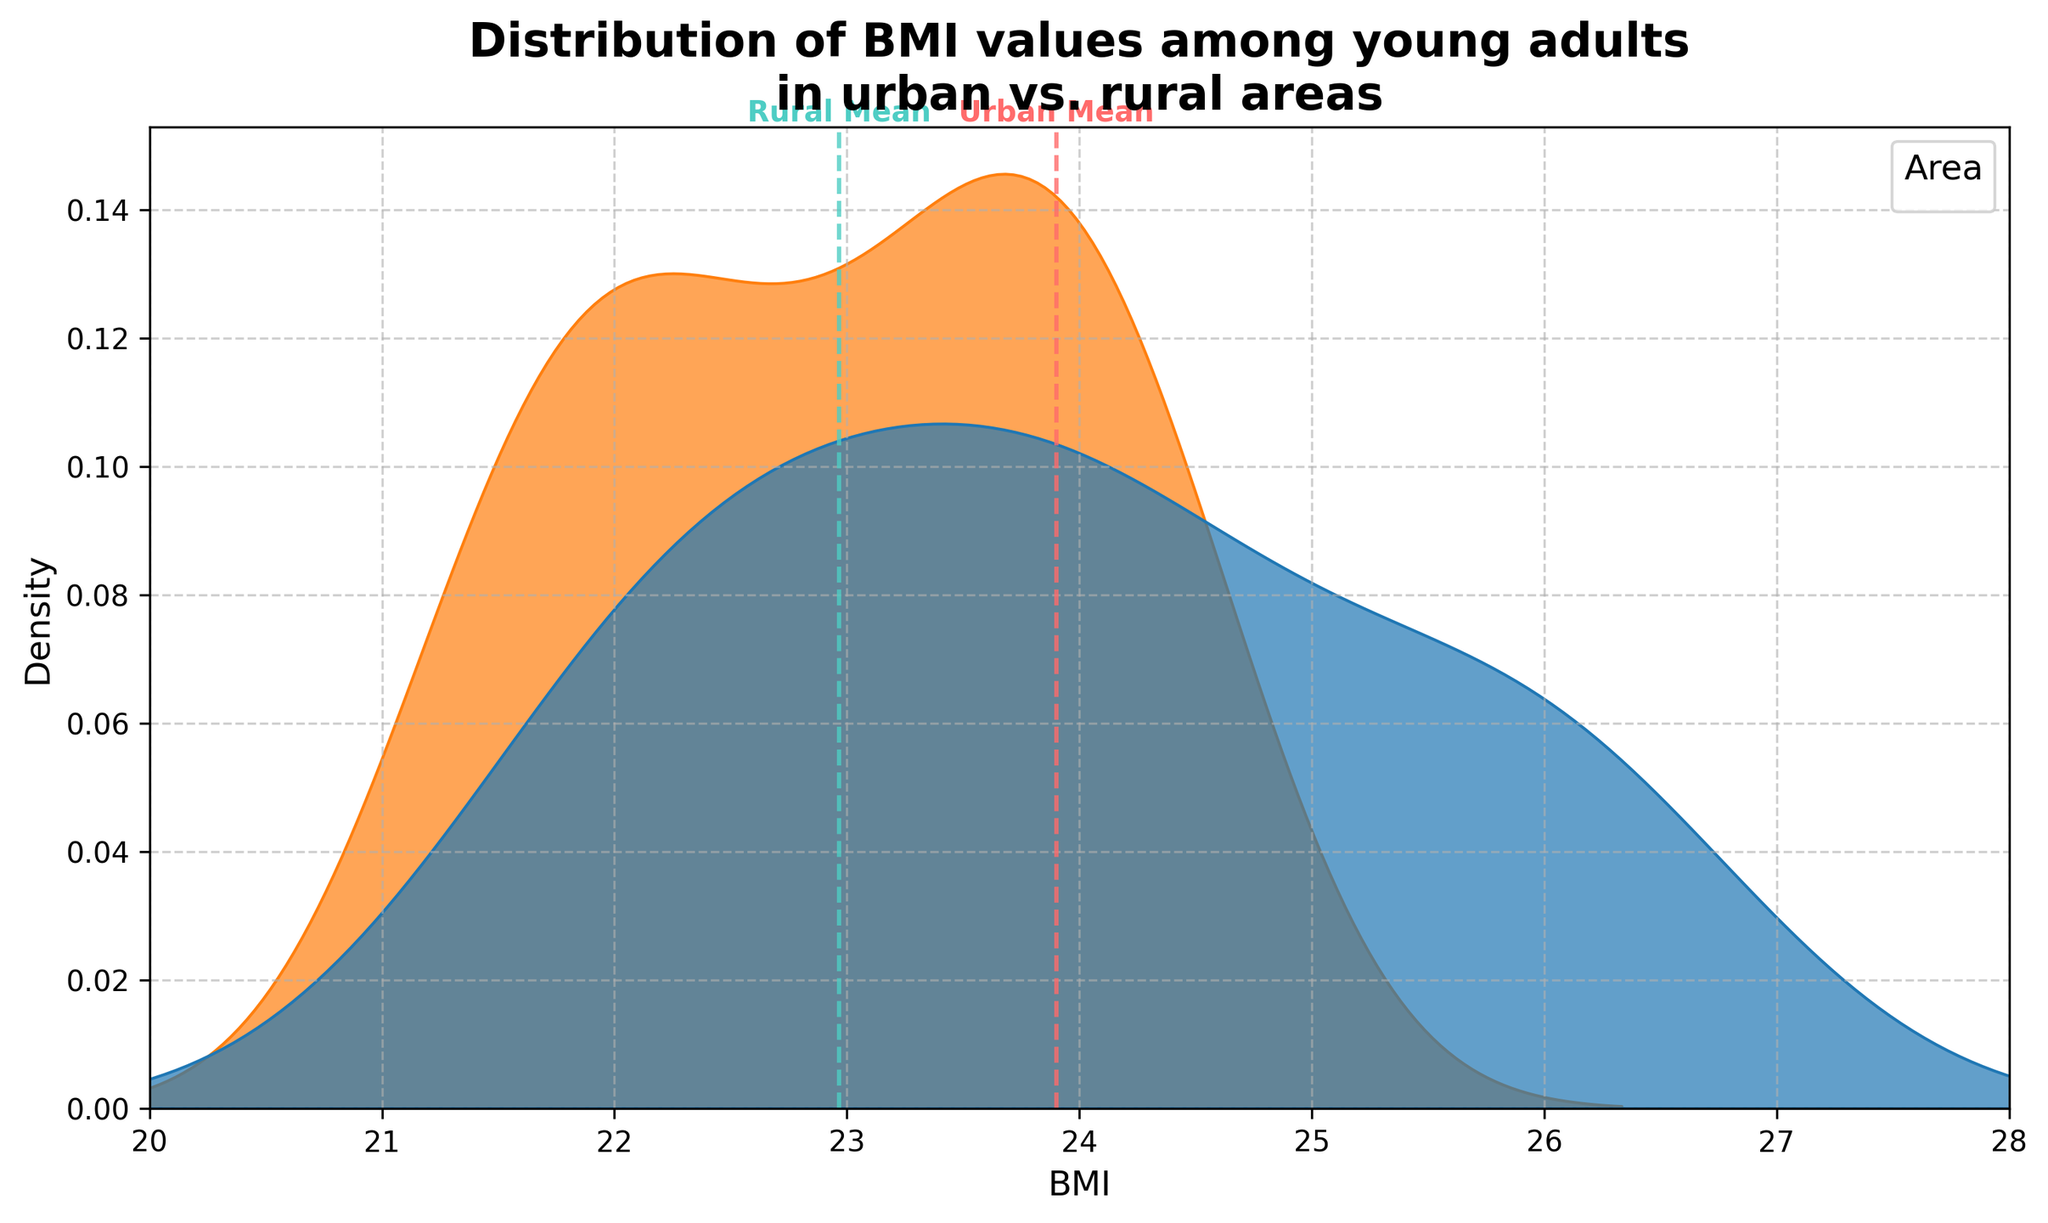What is the title of the figure? The title is located at the top of the figure and reads "Distribution of BMI values among young adults in urban vs. rural areas".
Answer: Distribution of BMI values among young adults in urban vs. rural areas What are the x-axis and y-axis labels? The x-axis is labeled 'BMI' and the y-axis is labeled 'Density'. This information is at the bottom and side of the plot, respectively.
Answer: BMI, Density What colors represent the urban and rural areas in the plot? The legend on the plot indicates that the color for urban is red and for rural is green. These colors correspond to the lines and shaded areas in the plot.
Answer: Urban: red, Rural: green Which area has a higher mean BMI value: urban or rural? The plot includes dashed vertical lines indicating the mean BMI values for each area. The urban mean is positioned to the right of the rural mean, indicating that the urban area has a higher mean BMI value.
Answer: Urban Identify one approximate BMI value for which the density of rural BMI is higher than that of urban BMI. By observing the plot, the density curve for the rural area is higher than the urban area around a BMI value of 24.1.
Answer: 24.1 What is the approximate range of BMI values displayed on the x-axis? By looking at the limits of the x-axis, the plotted range of BMI values extends from approximately 20 to 28.
Answer: 20 to 28 Which area shows a higher peak density in their BMI distribution? The plot shows that the rural area has a higher single peak density compared to the urban area. This can be identified by the height of the density curves.
Answer: Rural At approximately what BMI value do both urban and rural areas' density curves meet or cross each other? The plot indicates that the density curves for urban and rural areas intersect around a BMI value of 23.7.
Answer: 23.7 How does the shape of the distribution for the urban area differ from the rural area? The urban distribution shows a slightly bimodal shape with peaks around 24 and 26, whereas the rural distribution has a single peak around 23.5. This can be observed from the density curves' formations.
Answer: Urban: Bimodal, Rural: Single peak How does the spread of BMI values differ between urban and rural areas? The urban BMI distribution appears to have a wider spread with visible density extending further on both lower and higher BMI values compared to the rural distribution. This can be deduced from the width of the respective density curves.
Answer: Urban: Wider spread, Rural: Narrower spread 